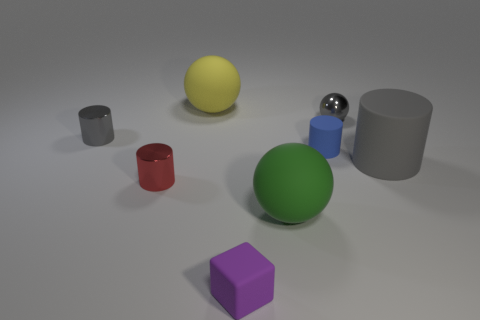Can you describe the arrangement of objects in terms of their proximity to one another? Certainly! In the image, we see a collection of differently colored geometric objects on a flat surface. The yellow sphere is positioned near the center, closely flanked by a large green sphere and a smaller blue sphere on its right. A red cylinder lies towards the yellow sphere's front left side, while a larger gray cylinder is situated a little further away to the back left. A small gray cylinder is off to the left in the background, creating a line that gradually increases in size with the red and larger gray cylinders. Finally, the purple cube is placed alone in the foreground, separated from the cluster of spherical objects. 